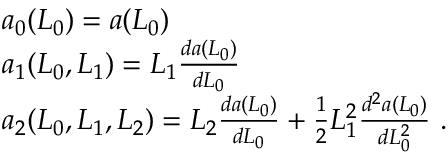Convert formula to latex. <formula><loc_0><loc_0><loc_500><loc_500>\begin{array} { r l } & { a _ { 0 } ( L _ { 0 } ) = a ( L _ { 0 } ) } \\ & { a _ { 1 } ( L _ { 0 } , L _ { 1 } ) = L _ { 1 } \frac { d a ( L _ { 0 } ) } { d L _ { 0 } } } \\ & { a _ { 2 } ( L _ { 0 } , L _ { 1 } , L _ { 2 } ) = L _ { 2 } \frac { d a ( L _ { 0 } ) } { d L _ { 0 } } + \frac { 1 } { 2 } L _ { 1 } ^ { 2 } \frac { d ^ { 2 } a ( L _ { 0 } ) } { d L _ { 0 } ^ { 2 } } \ . } \end{array}</formula> 